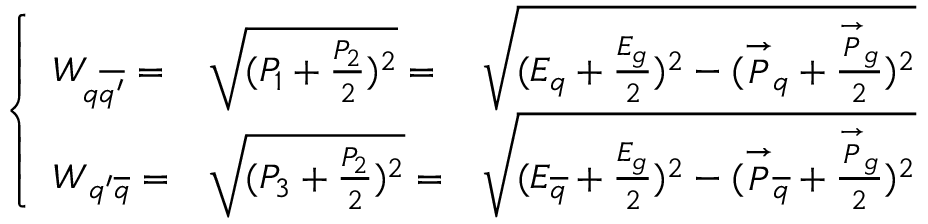Convert formula to latex. <formula><loc_0><loc_0><loc_500><loc_500>\left \{ \begin{array} { l l l } { { W _ { q { \overline { { { q ^ { \prime } } } } } } = } } & { { \sqrt { ( P _ { 1 } + { \frac { P _ { 2 } } { 2 } } ) ^ { 2 } } = } } & { { \sqrt { ( E _ { q } + { \frac { E _ { g } } { 2 } } ) ^ { 2 } - ( { \stackrel { \rightarrow } P _ { q } } + { \frac { \stackrel { \rightarrow } P _ { g } } { 2 } } ) ^ { 2 } } } } \\ { { W _ { { q ^ { \prime } } { \overline { q } } } = } } & { { \sqrt { ( P _ { 3 } + { \frac { P _ { 2 } } { 2 } } ) ^ { 2 } } = } } & { { \sqrt { ( E _ { \overline { q } } + { \frac { E _ { g } } { 2 } } ) ^ { 2 } - ( { \stackrel { \rightarrow } P _ { \overline { q } } } + { \frac { \stackrel { \rightarrow } P _ { g } } { 2 } } ) ^ { 2 } } } } \end{array}</formula> 